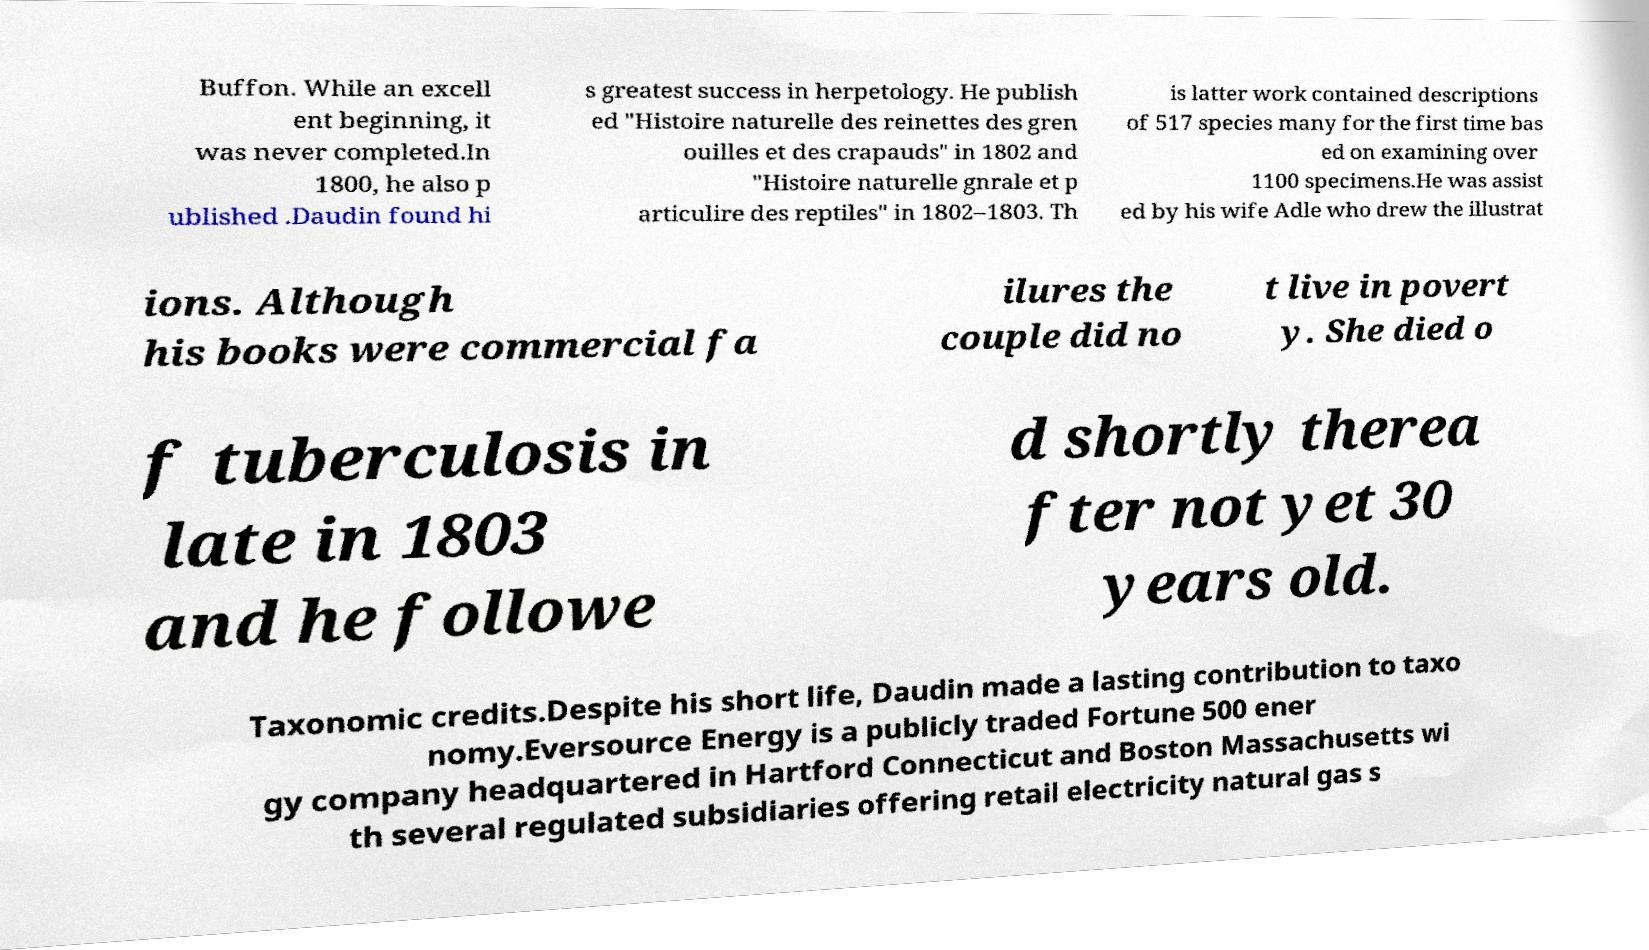Please identify and transcribe the text found in this image. Buffon. While an excell ent beginning, it was never completed.In 1800, he also p ublished .Daudin found hi s greatest success in herpetology. He publish ed "Histoire naturelle des reinettes des gren ouilles et des crapauds" in 1802 and "Histoire naturelle gnrale et p articulire des reptiles" in 1802–1803. Th is latter work contained descriptions of 517 species many for the first time bas ed on examining over 1100 specimens.He was assist ed by his wife Adle who drew the illustrat ions. Although his books were commercial fa ilures the couple did no t live in povert y. She died o f tuberculosis in late in 1803 and he followe d shortly therea fter not yet 30 years old. Taxonomic credits.Despite his short life, Daudin made a lasting contribution to taxo nomy.Eversource Energy is a publicly traded Fortune 500 ener gy company headquartered in Hartford Connecticut and Boston Massachusetts wi th several regulated subsidiaries offering retail electricity natural gas s 